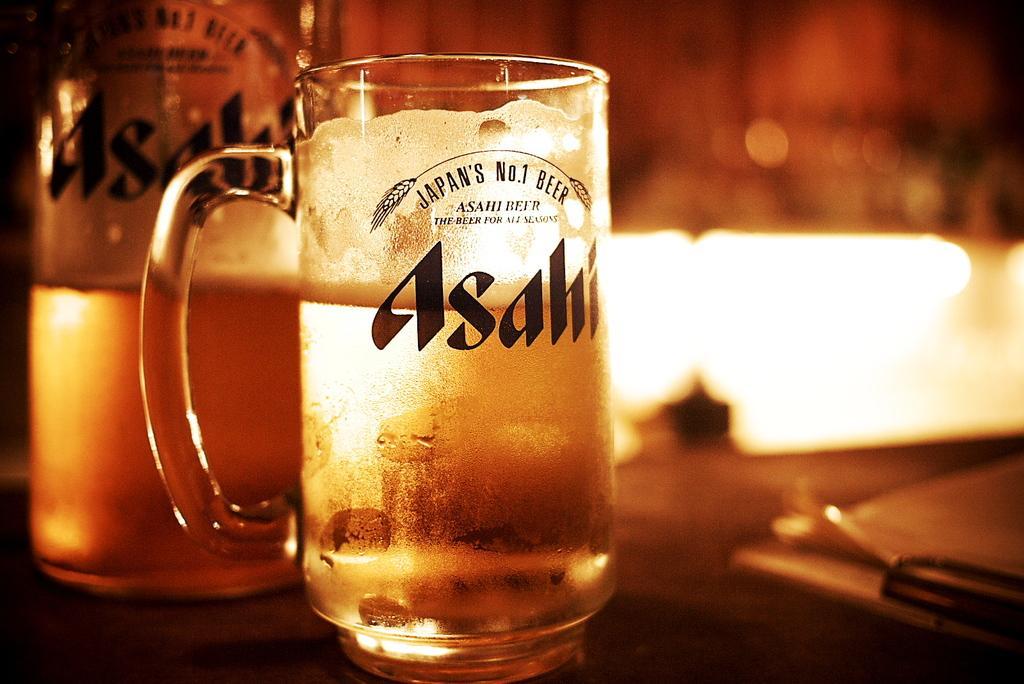Can you describe this image briefly? In the image there is a beer glass on a table and beside it there is a beer bottle. 